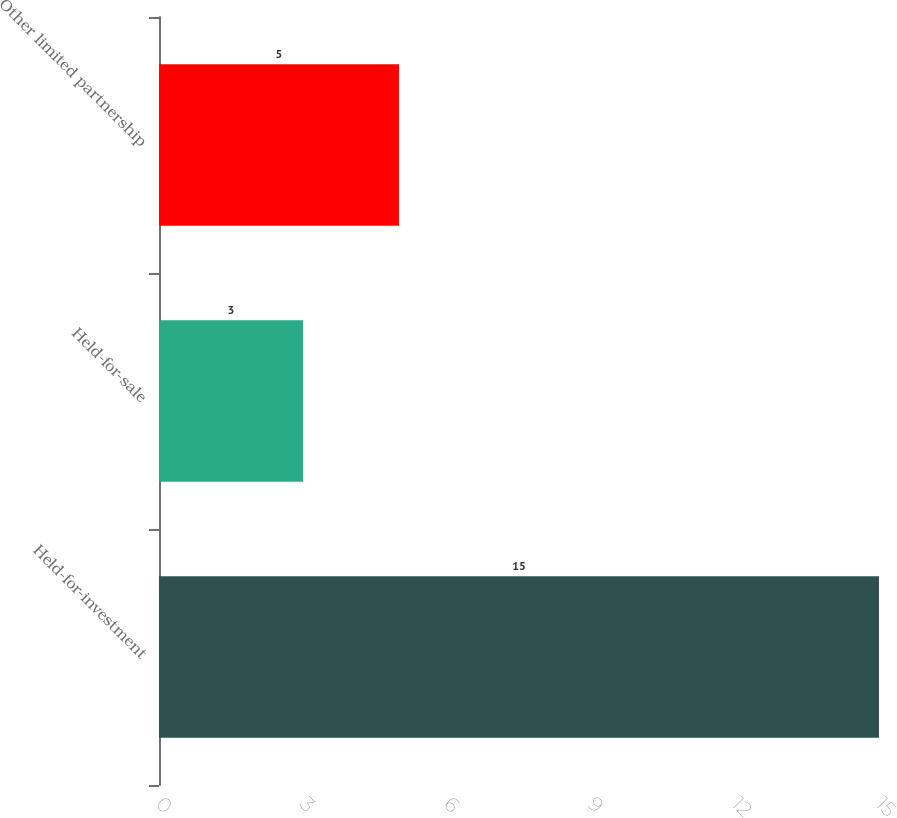<chart> <loc_0><loc_0><loc_500><loc_500><bar_chart><fcel>Held-for-investment<fcel>Held-for-sale<fcel>Other limited partnership<nl><fcel>15<fcel>3<fcel>5<nl></chart> 